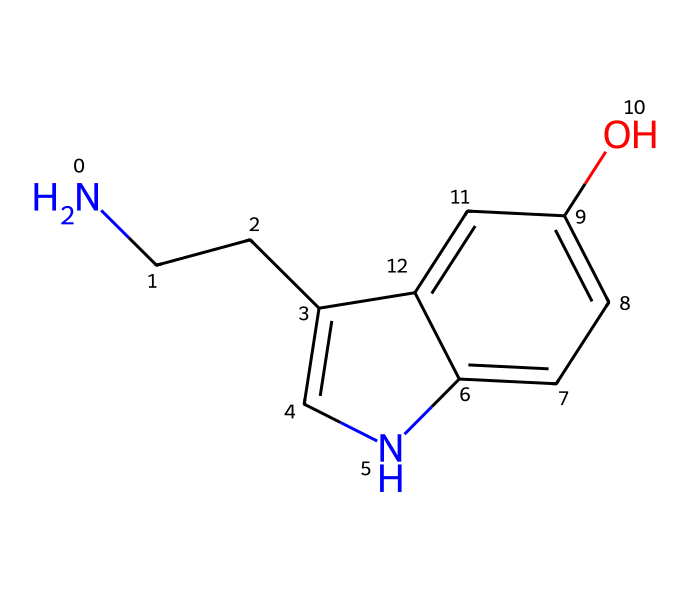What is the main functional group present in this chemical? The chemical structure shows a hydroxyl group (-OH) attached to the aromatic ring, which is characteristic of phenols.
Answer: hydroxyl How many carbon atoms are in this chemical? By analyzing the SMILES representation, we can count the number of carbon atoms present. The structure includes 10 carbon atoms in total.
Answer: 10 What type of molecule is serotonin classified as? Serotonin is classified as a biogenic amine due to the presence of an amine group and its derivation from an amino acid.
Answer: biogenic amine What role does this chemical play in the body? Serotonin is known primarily as a neurotransmitter, influencing mood and emotional regulation, which is crucial for mental well-being.
Answer: neurotransmitter How does the nitrogen in this chemical affect its function? The nitrogen atom in the chemical structure is part of the amine functional group, which contributes to its ability to interact with receptors in the brain, influencing mood regulation.
Answer: interacts with receptors 